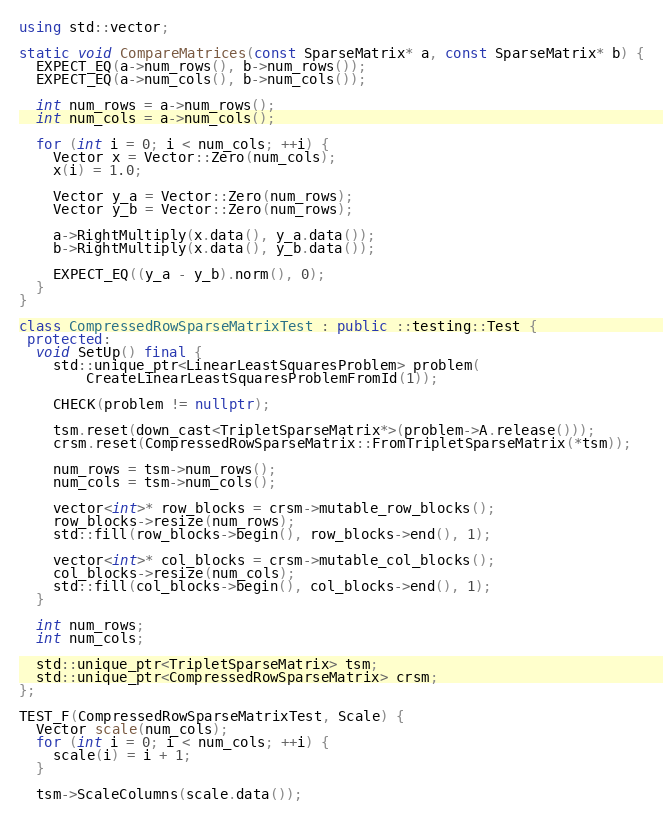<code> <loc_0><loc_0><loc_500><loc_500><_C++_>
using std::vector;

static void CompareMatrices(const SparseMatrix* a, const SparseMatrix* b) {
  EXPECT_EQ(a->num_rows(), b->num_rows());
  EXPECT_EQ(a->num_cols(), b->num_cols());

  int num_rows = a->num_rows();
  int num_cols = a->num_cols();

  for (int i = 0; i < num_cols; ++i) {
    Vector x = Vector::Zero(num_cols);
    x(i) = 1.0;

    Vector y_a = Vector::Zero(num_rows);
    Vector y_b = Vector::Zero(num_rows);

    a->RightMultiply(x.data(), y_a.data());
    b->RightMultiply(x.data(), y_b.data());

    EXPECT_EQ((y_a - y_b).norm(), 0);
  }
}

class CompressedRowSparseMatrixTest : public ::testing::Test {
 protected:
  void SetUp() final {
    std::unique_ptr<LinearLeastSquaresProblem> problem(
        CreateLinearLeastSquaresProblemFromId(1));

    CHECK(problem != nullptr);

    tsm.reset(down_cast<TripletSparseMatrix*>(problem->A.release()));
    crsm.reset(CompressedRowSparseMatrix::FromTripletSparseMatrix(*tsm));

    num_rows = tsm->num_rows();
    num_cols = tsm->num_cols();

    vector<int>* row_blocks = crsm->mutable_row_blocks();
    row_blocks->resize(num_rows);
    std::fill(row_blocks->begin(), row_blocks->end(), 1);

    vector<int>* col_blocks = crsm->mutable_col_blocks();
    col_blocks->resize(num_cols);
    std::fill(col_blocks->begin(), col_blocks->end(), 1);
  }

  int num_rows;
  int num_cols;

  std::unique_ptr<TripletSparseMatrix> tsm;
  std::unique_ptr<CompressedRowSparseMatrix> crsm;
};

TEST_F(CompressedRowSparseMatrixTest, Scale) {
  Vector scale(num_cols);
  for (int i = 0; i < num_cols; ++i) {
    scale(i) = i + 1;
  }

  tsm->ScaleColumns(scale.data());</code> 